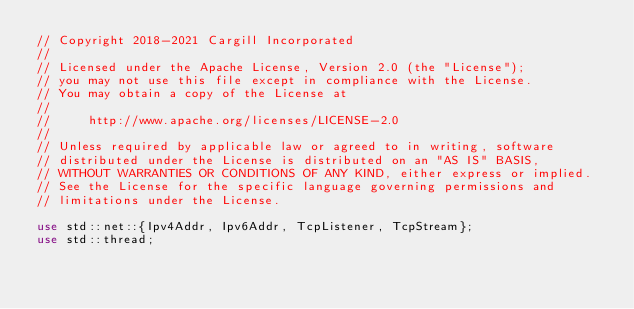<code> <loc_0><loc_0><loc_500><loc_500><_Rust_>// Copyright 2018-2021 Cargill Incorporated
//
// Licensed under the Apache License, Version 2.0 (the "License");
// you may not use this file except in compliance with the License.
// You may obtain a copy of the License at
//
//     http://www.apache.org/licenses/LICENSE-2.0
//
// Unless required by applicable law or agreed to in writing, software
// distributed under the License is distributed on an "AS IS" BASIS,
// WITHOUT WARRANTIES OR CONDITIONS OF ANY KIND, either express or implied.
// See the License for the specific language governing permissions and
// limitations under the License.

use std::net::{Ipv4Addr, Ipv6Addr, TcpListener, TcpStream};
use std::thread;</code> 